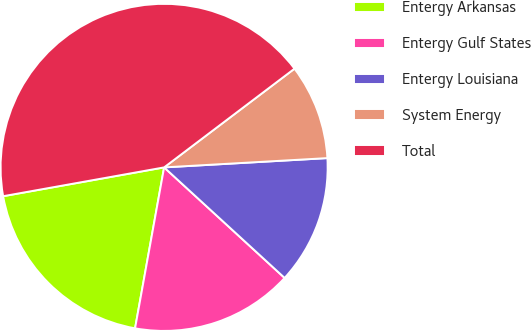Convert chart. <chart><loc_0><loc_0><loc_500><loc_500><pie_chart><fcel>Entergy Arkansas<fcel>Entergy Gulf States<fcel>Entergy Louisiana<fcel>System Energy<fcel>Total<nl><fcel>19.34%<fcel>16.03%<fcel>12.72%<fcel>9.41%<fcel>42.51%<nl></chart> 